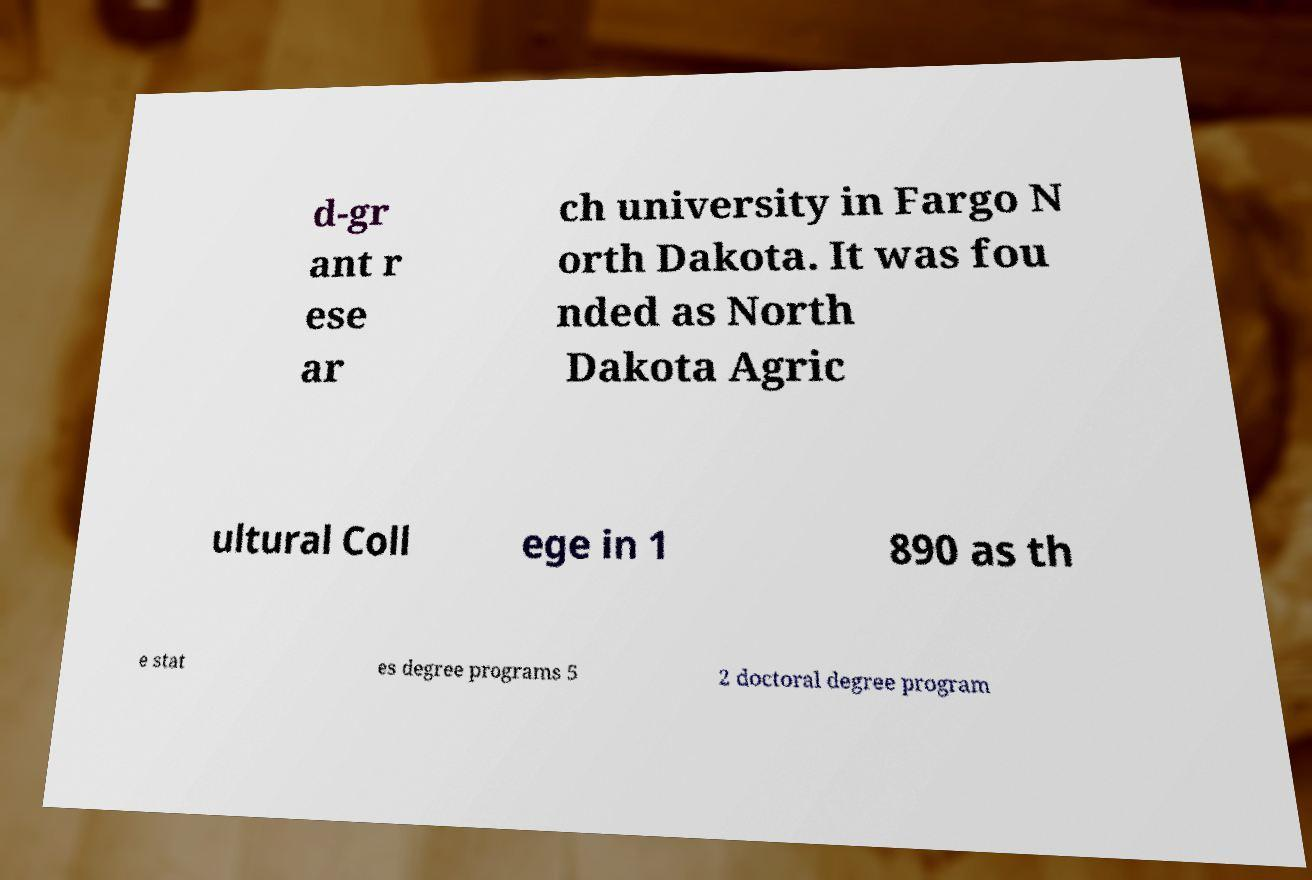Could you extract and type out the text from this image? d-gr ant r ese ar ch university in Fargo N orth Dakota. It was fou nded as North Dakota Agric ultural Coll ege in 1 890 as th e stat es degree programs 5 2 doctoral degree program 